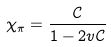Convert formula to latex. <formula><loc_0><loc_0><loc_500><loc_500>\chi _ { \pi } = \frac { \mathcal { C } } { 1 - 2 v { \mathcal { C } } }</formula> 